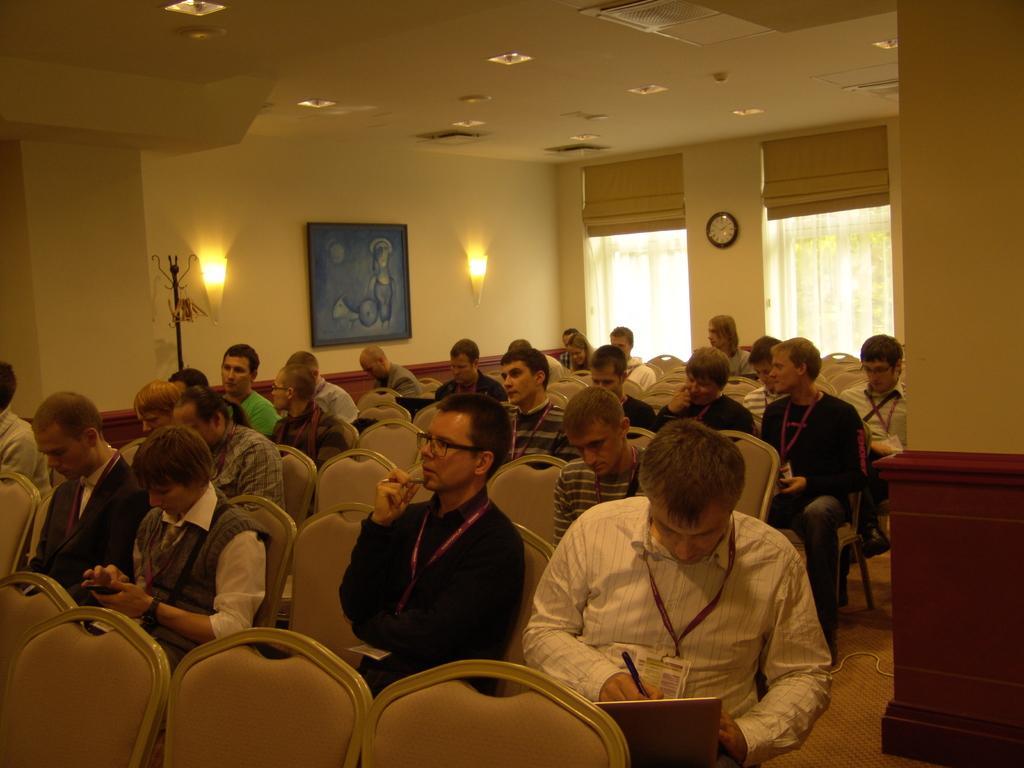Could you give a brief overview of what you see in this image? In this picture we can see a group of people sitting on chairs were some of them were id cards and holding pens with their hands and in the background we can see the lights, clock and a frame on the wall. 